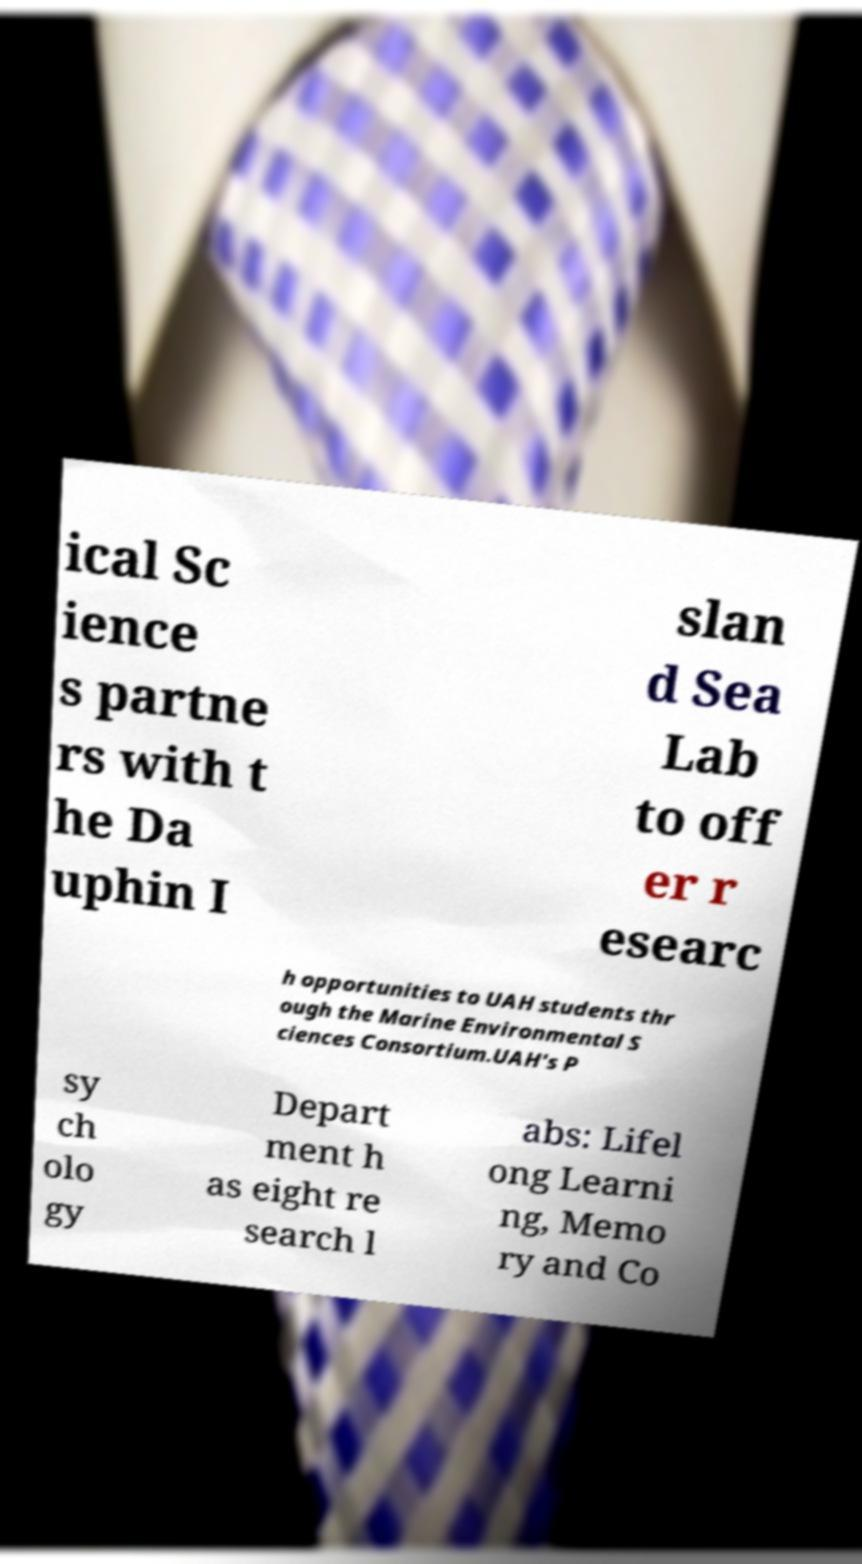Please read and relay the text visible in this image. What does it say? ical Sc ience s partne rs with t he Da uphin I slan d Sea Lab to off er r esearc h opportunities to UAH students thr ough the Marine Environmental S ciences Consortium.UAH's P sy ch olo gy Depart ment h as eight re search l abs: Lifel ong Learni ng, Memo ry and Co 